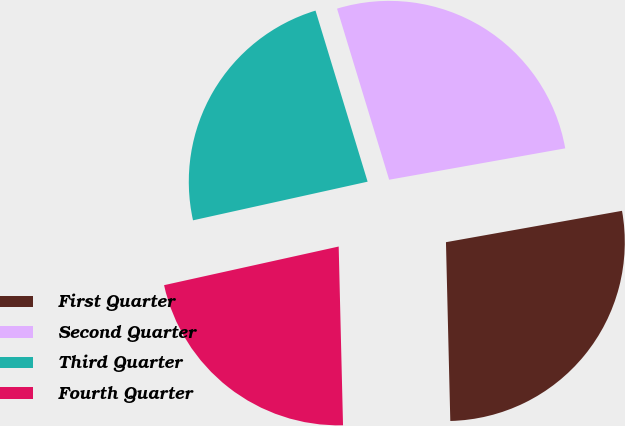<chart> <loc_0><loc_0><loc_500><loc_500><pie_chart><fcel>First Quarter<fcel>Second Quarter<fcel>Third Quarter<fcel>Fourth Quarter<nl><fcel>27.42%<fcel>26.9%<fcel>23.76%<fcel>21.92%<nl></chart> 